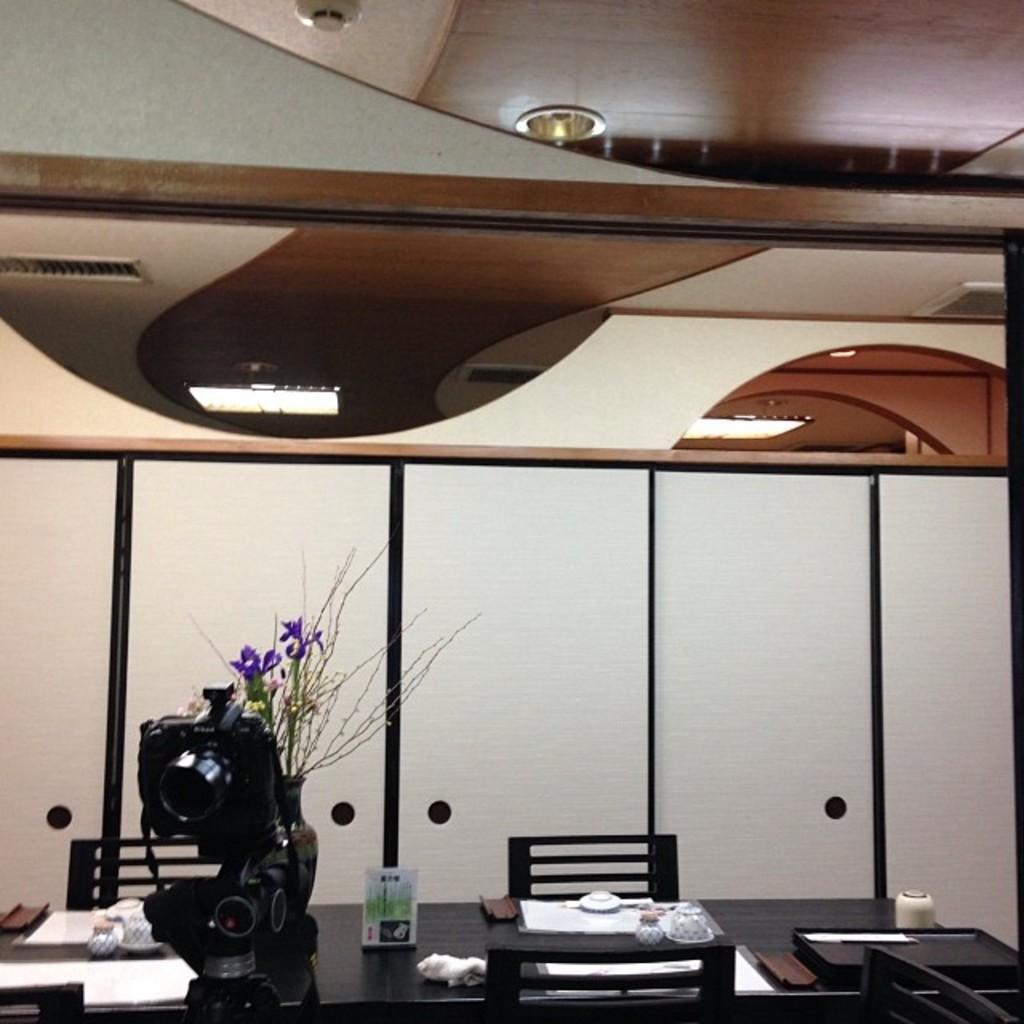Please provide a concise description of this image. The picture is taken inside a room. At the bottom on a table there are papers, bouquet, pot and few other things are there. This is a camera. There are chairs over here. This is the ceiling. 